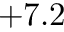Convert formula to latex. <formula><loc_0><loc_0><loc_500><loc_500>+ 7 . 2</formula> 